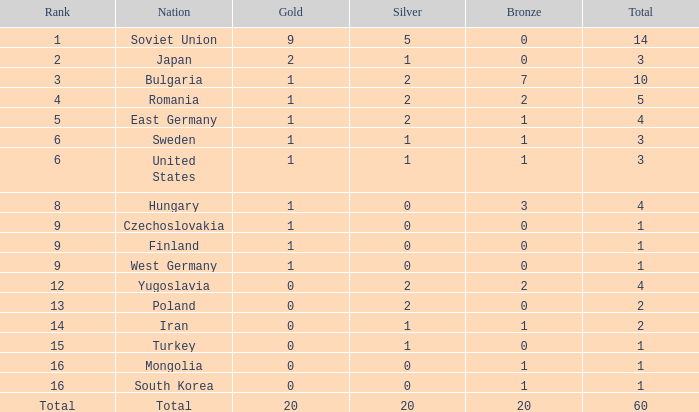How many bronze medals are there in total if there are more than 5 silvers and fewer than 20 golds? None. 